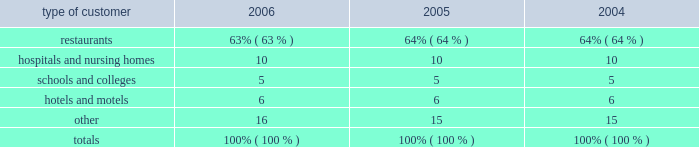Customers and products the foodservice industry consists of two major customer types 2014 2018 2018traditional 2019 2019 and 2018 2018chain restaurant . 2019 2019 traditional foodservice customers include restaurants , hospitals , schools , hotels and industrial caterers .
Sysco 2019s chain restaurant customers include regional and national hamburger , sandwich , pizza , chicken , steak and other chain operations .
Services to the company 2019s traditional foodservice and chain restaurant customers are supported by similar physical facilities , vehicles , material handling equipment and techniques , and administrative and operating staffs .
Products distributed by the company include a full line of frozen foods , such as meats , fully prepared entrees , fruits , vegetables and desserts ; a full line of canned and dry foods ; fresh meats ; imported specialties ; and fresh produce .
The company also supplies a wide variety of non-food items , including : paper products such as disposable napkins , plates and cups ; tableware such as china and silverware ; cookware such as pots , pans and utensils ; restaurant and kitchen equipment and supplies ; and cleaning supplies .
Sysco 2019s operating companies distribute nationally-branded merchandise , as well as products packaged under sysco 2019s private brands .
The company believes that prompt and accurate delivery of orders , close contact with customers and the ability to provide a full array of products and services to assist customers in their foodservice operations are of primary importance in the marketing and distribution of products to traditional customers .
Sysco 2019s operating companies offer daily delivery to certain customer locations and have the capability of delivering special orders on short notice .
Through the more than 13900 sales and marketing representatives and support staff of sysco and its operating companies , sysco stays informed of the needs of its customers and acquaints them with new products and services .
Sysco 2019s operating companies also provide ancillary services relating to foodservice distribution , such as providing customers with product usage reports and other data , menu-planning advice , food safety training and assistance in inventory control , as well as access to various third party services designed to add value to our customers 2019 businesses .
No single customer accounted for 10% ( 10 % ) or more of sysco 2019s total sales for its fiscal year ended july 1 , 2006 .
Sysco 2019s sales to chain restaurant customers consist of a variety of food products .
The company believes that consistent product quality and timely and accurate service are important factors in the selection of a chain restaurant supplier .
One chain restaurant customer ( wendy 2019s international , inc. ) accounted for 5% ( 5 % ) of sysco 2019s sales for its fiscal year ended july 1 , 2006 .
Although this customer represents approximately 37% ( 37 % ) of the sygma segment sales , the company does not believe that the loss of this customer would have a material adverse effect on sysco as a whole .
Based upon available information , the company estimates that sales by type of customer during the past three fiscal years were as follows: .
Restaurants **************************************************************** 63% ( 63 % ) 64% ( 64 % ) 64% ( 64 % ) hospitals and nursing homes *************************************************** 10 10 10 schools and colleges ********************************************************* 5 5 5 hotels and motels *********************************************************** 6 6 6 other********************************************************************* 16 15 15 totals ****************************************************************** 100% ( 100 % ) 100% ( 100 % ) 100% ( 100 % ) sources of supply sysco purchases from thousands of suppliers , none of which individually accounts for more than 10% ( 10 % ) of the company 2019s purchases .
These suppliers consist generally of large corporations selling brand name and private label merchandise and independent regional brand and private label processors and packers .
Generally , purchasing is carried out through centrally developed purchasing programs and direct purchasing programs established by the company 2019s various operating companies .
The company continually develops relationships with suppliers but has no material long-term purchase commitments with any supplier .
In the second quarter of fiscal 2002 , sysco began a project to restructure its supply chain ( national supply chain project ) .
This project is intended to increase profitability by lowering aggregate inventory levels , operating costs , and future facility expansion needs at sysco 2019s broadline operating companies while providing greater value to our suppliers and customers .
%%transmsg*** transmitting job : h39408 pcn : 004000000 *** %%pcmsg|2 |00010|yes|no|09/06/2006 17:07|0|1|page is valid , no graphics -- color : n| .
What was the change in percentage sales to restaurants from 2004 to 2005? 
Computations: (64% - 64%)
Answer: 0.0. 